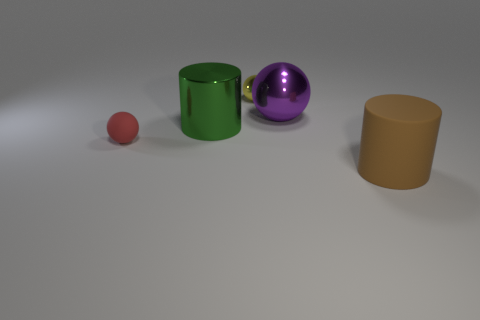What number of rubber things are on the left side of the big thing on the left side of the tiny metal sphere?
Provide a short and direct response. 1. Are any red rubber objects visible?
Provide a succinct answer. Yes. What number of other objects are there of the same color as the rubber cylinder?
Give a very brief answer. 0. Are there fewer tiny purple metallic cylinders than brown cylinders?
Your response must be concise. Yes. What shape is the metal thing in front of the metallic ball to the right of the small yellow ball?
Your answer should be very brief. Cylinder. Are there any brown matte things on the right side of the small rubber thing?
Offer a terse response. Yes. There is a metallic ball that is the same size as the rubber ball; what is its color?
Your answer should be compact. Yellow. How many big brown objects are the same material as the brown cylinder?
Make the answer very short. 0. What number of other objects are there of the same size as the green thing?
Provide a short and direct response. 2. Are there any brown cylinders that have the same size as the green metallic object?
Offer a terse response. Yes. 